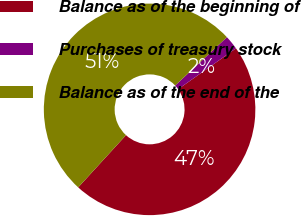Convert chart. <chart><loc_0><loc_0><loc_500><loc_500><pie_chart><fcel>Balance as of the beginning of<fcel>Purchases of treasury stock<fcel>Balance as of the end of the<nl><fcel>46.59%<fcel>2.17%<fcel>51.25%<nl></chart> 